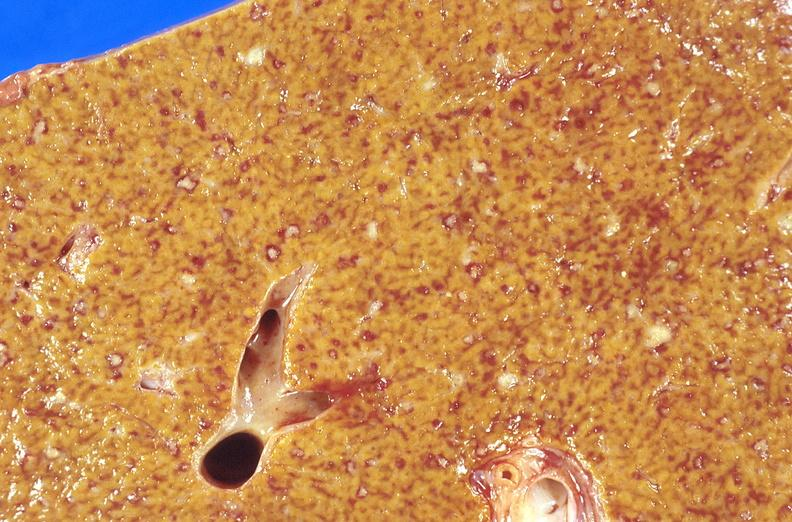what does this image show?
Answer the question using a single word or phrase. Liver 